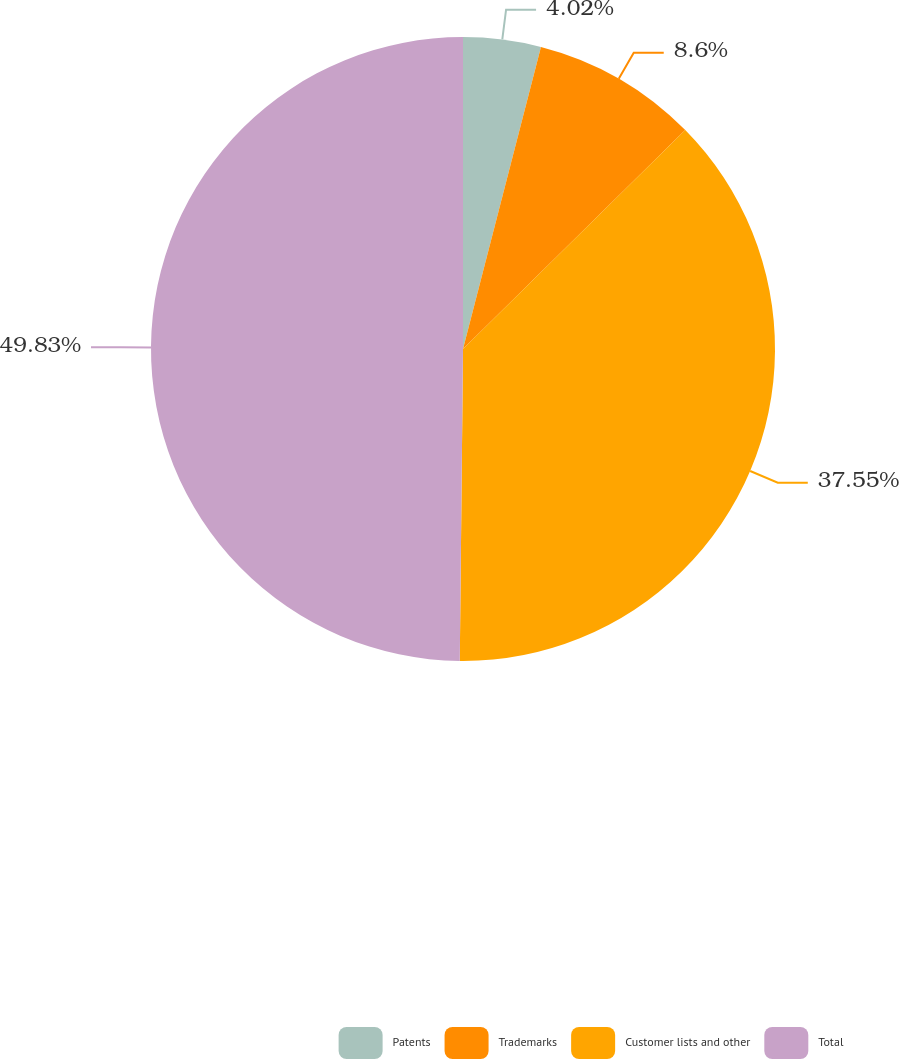Convert chart. <chart><loc_0><loc_0><loc_500><loc_500><pie_chart><fcel>Patents<fcel>Trademarks<fcel>Customer lists and other<fcel>Total<nl><fcel>4.02%<fcel>8.6%<fcel>37.55%<fcel>49.84%<nl></chart> 